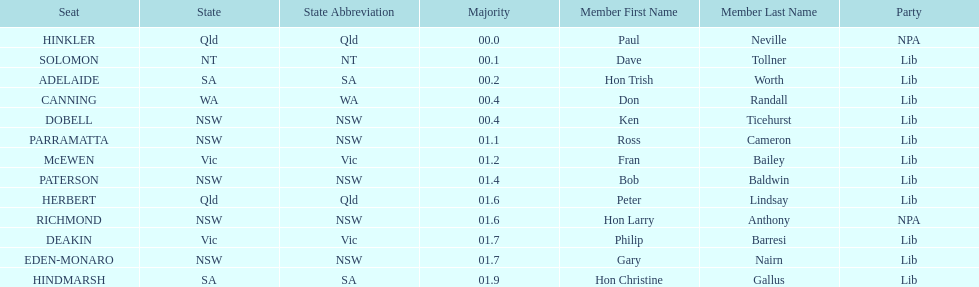What is the total of seats? 13. 